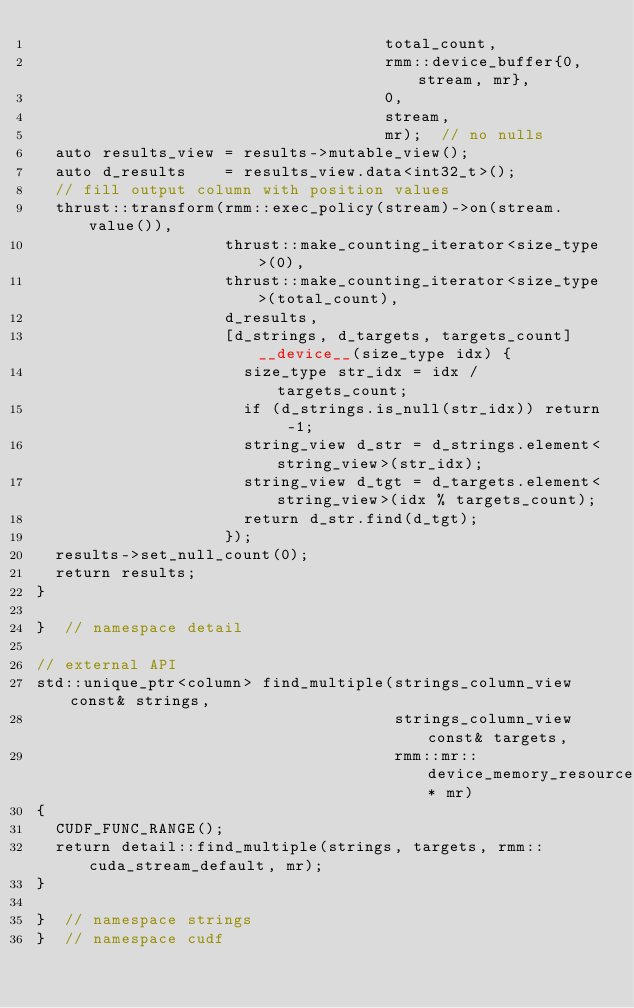Convert code to text. <code><loc_0><loc_0><loc_500><loc_500><_Cuda_>                                     total_count,
                                     rmm::device_buffer{0, stream, mr},
                                     0,
                                     stream,
                                     mr);  // no nulls
  auto results_view = results->mutable_view();
  auto d_results    = results_view.data<int32_t>();
  // fill output column with position values
  thrust::transform(rmm::exec_policy(stream)->on(stream.value()),
                    thrust::make_counting_iterator<size_type>(0),
                    thrust::make_counting_iterator<size_type>(total_count),
                    d_results,
                    [d_strings, d_targets, targets_count] __device__(size_type idx) {
                      size_type str_idx = idx / targets_count;
                      if (d_strings.is_null(str_idx)) return -1;
                      string_view d_str = d_strings.element<string_view>(str_idx);
                      string_view d_tgt = d_targets.element<string_view>(idx % targets_count);
                      return d_str.find(d_tgt);
                    });
  results->set_null_count(0);
  return results;
}

}  // namespace detail

// external API
std::unique_ptr<column> find_multiple(strings_column_view const& strings,
                                      strings_column_view const& targets,
                                      rmm::mr::device_memory_resource* mr)
{
  CUDF_FUNC_RANGE();
  return detail::find_multiple(strings, targets, rmm::cuda_stream_default, mr);
}

}  // namespace strings
}  // namespace cudf
</code> 